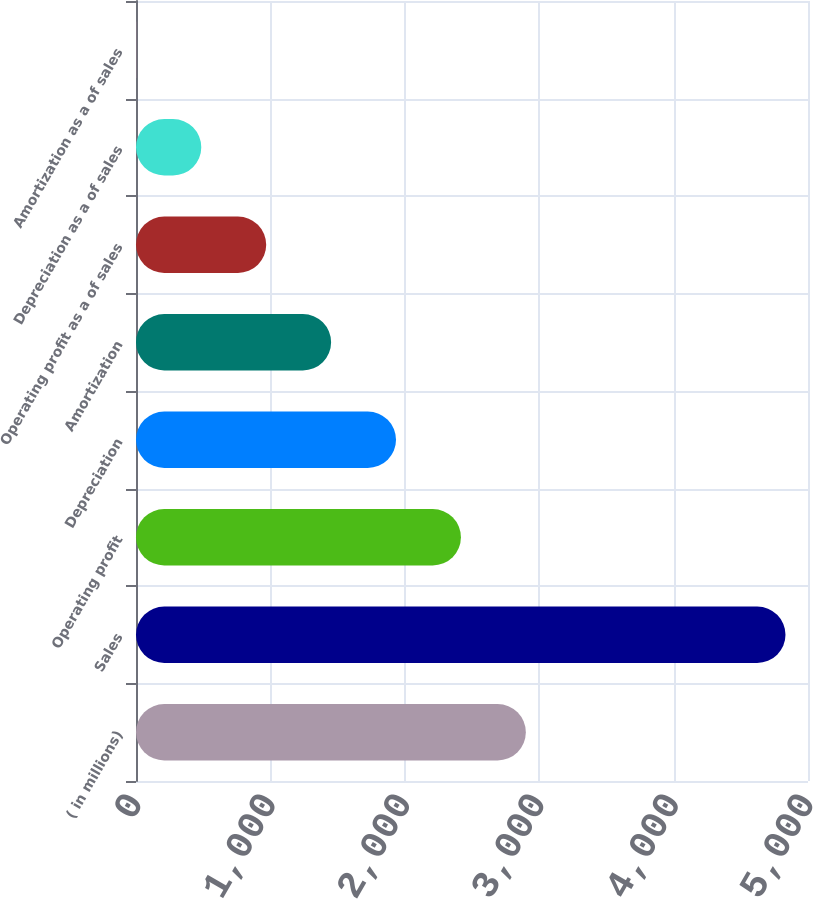Convert chart. <chart><loc_0><loc_0><loc_500><loc_500><bar_chart><fcel>( in millions)<fcel>Sales<fcel>Operating profit<fcel>Depreciation<fcel>Amortization<fcel>Operating profit as a of sales<fcel>Depreciation as a of sales<fcel>Amortization as a of sales<nl><fcel>2900.62<fcel>4832.5<fcel>2417.65<fcel>1934.68<fcel>1451.71<fcel>968.74<fcel>485.77<fcel>2.8<nl></chart> 